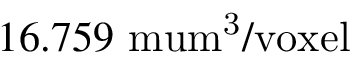<formula> <loc_0><loc_0><loc_500><loc_500>1 6 . 7 5 9 \ m u m ^ { 3 } / v o x e l</formula> 